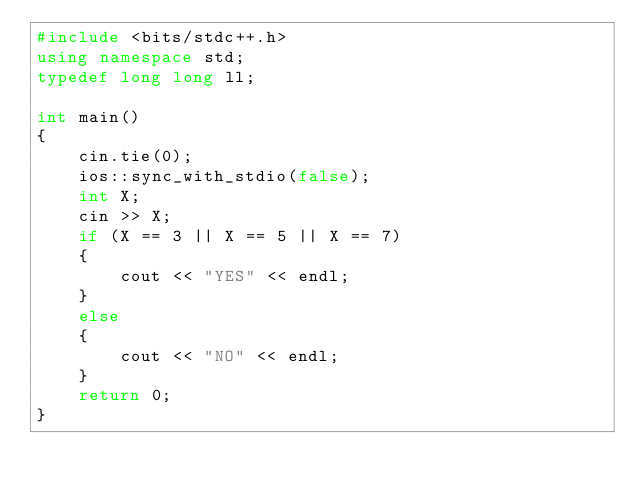<code> <loc_0><loc_0><loc_500><loc_500><_C++_>#include <bits/stdc++.h>
using namespace std;
typedef long long ll;

int main()
{
    cin.tie(0);
    ios::sync_with_stdio(false);
    int X;
    cin >> X;
    if (X == 3 || X == 5 || X == 7)
    {
        cout << "YES" << endl;
    }
    else
    {
        cout << "NO" << endl;
    }
    return 0;
}</code> 